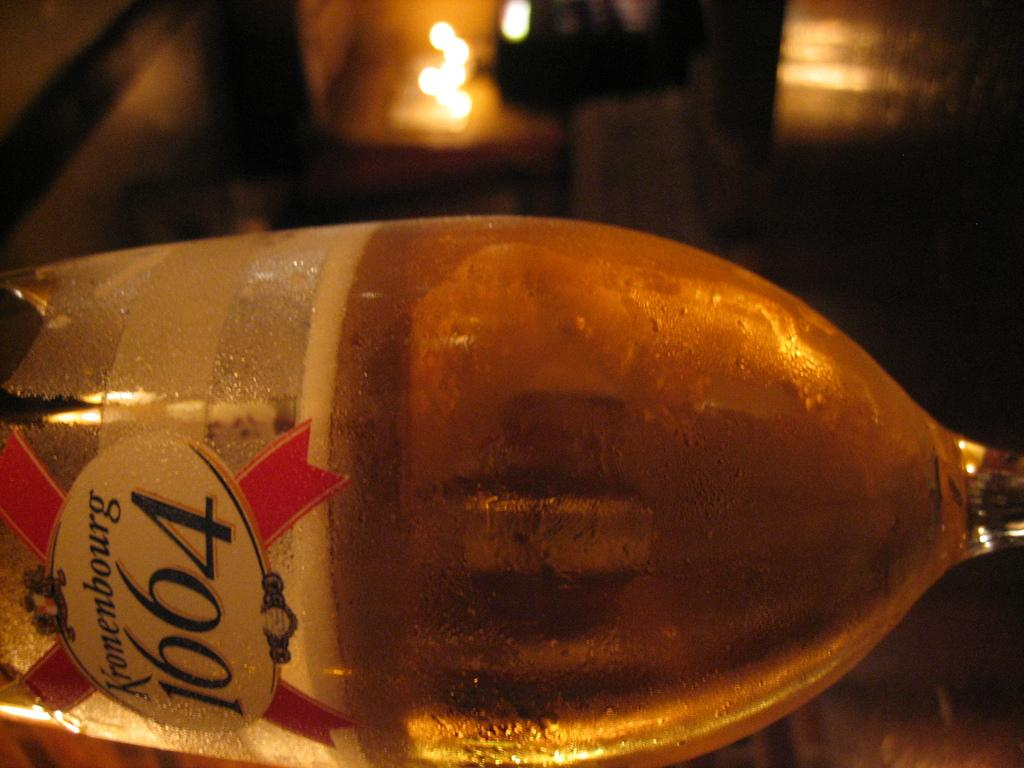<image>
Create a compact narrative representing the image presented. A glass of beer that says Kronenbourg and the nummbers 1664 